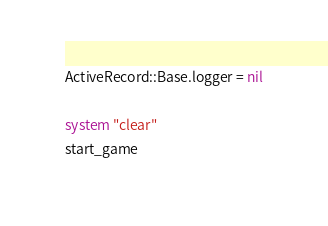<code> <loc_0><loc_0><loc_500><loc_500><_Ruby_>ActiveRecord::Base.logger = nil

system "clear"
start_game
</code> 